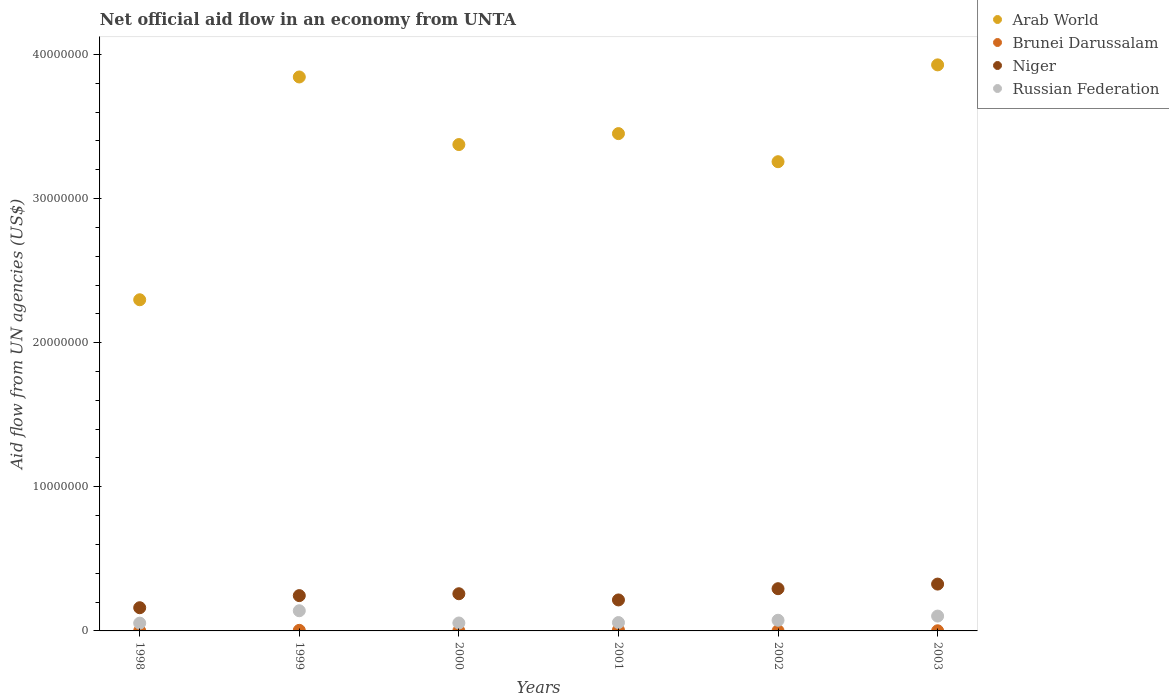How many different coloured dotlines are there?
Offer a very short reply. 4. What is the net official aid flow in Arab World in 1999?
Give a very brief answer. 3.84e+07. Across all years, what is the maximum net official aid flow in Russian Federation?
Your response must be concise. 1.40e+06. Across all years, what is the minimum net official aid flow in Russian Federation?
Provide a succinct answer. 5.40e+05. What is the total net official aid flow in Brunei Darussalam in the graph?
Offer a terse response. 1.40e+05. What is the difference between the net official aid flow in Arab World in 2000 and that in 2003?
Make the answer very short. -5.53e+06. What is the difference between the net official aid flow in Russian Federation in 2002 and the net official aid flow in Arab World in 1999?
Provide a succinct answer. -3.77e+07. What is the average net official aid flow in Arab World per year?
Offer a very short reply. 3.36e+07. In the year 2003, what is the difference between the net official aid flow in Brunei Darussalam and net official aid flow in Niger?
Make the answer very short. -3.24e+06. What is the ratio of the net official aid flow in Russian Federation in 1998 to that in 2002?
Provide a short and direct response. 0.73. Is the net official aid flow in Arab World in 2001 less than that in 2003?
Offer a terse response. Yes. Is the difference between the net official aid flow in Brunei Darussalam in 1999 and 2001 greater than the difference between the net official aid flow in Niger in 1999 and 2001?
Make the answer very short. No. What is the difference between the highest and the second highest net official aid flow in Russian Federation?
Provide a succinct answer. 3.70e+05. What is the difference between the highest and the lowest net official aid flow in Brunei Darussalam?
Your answer should be compact. 5.00e+04. Is the sum of the net official aid flow in Niger in 1998 and 2001 greater than the maximum net official aid flow in Arab World across all years?
Your response must be concise. No. Does the net official aid flow in Niger monotonically increase over the years?
Make the answer very short. No. Is the net official aid flow in Arab World strictly greater than the net official aid flow in Brunei Darussalam over the years?
Keep it short and to the point. Yes. Is the net official aid flow in Brunei Darussalam strictly less than the net official aid flow in Arab World over the years?
Make the answer very short. Yes. How many dotlines are there?
Your answer should be compact. 4. How many years are there in the graph?
Offer a very short reply. 6. What is the difference between two consecutive major ticks on the Y-axis?
Offer a terse response. 1.00e+07. Are the values on the major ticks of Y-axis written in scientific E-notation?
Keep it short and to the point. No. How many legend labels are there?
Make the answer very short. 4. How are the legend labels stacked?
Offer a very short reply. Vertical. What is the title of the graph?
Make the answer very short. Net official aid flow in an economy from UNTA. What is the label or title of the X-axis?
Offer a very short reply. Years. What is the label or title of the Y-axis?
Make the answer very short. Aid flow from UN agencies (US$). What is the Aid flow from UN agencies (US$) of Arab World in 1998?
Your answer should be compact. 2.30e+07. What is the Aid flow from UN agencies (US$) in Niger in 1998?
Provide a short and direct response. 1.61e+06. What is the Aid flow from UN agencies (US$) in Russian Federation in 1998?
Offer a terse response. 5.40e+05. What is the Aid flow from UN agencies (US$) of Arab World in 1999?
Ensure brevity in your answer.  3.84e+07. What is the Aid flow from UN agencies (US$) in Brunei Darussalam in 1999?
Provide a succinct answer. 4.00e+04. What is the Aid flow from UN agencies (US$) of Niger in 1999?
Ensure brevity in your answer.  2.45e+06. What is the Aid flow from UN agencies (US$) in Russian Federation in 1999?
Provide a succinct answer. 1.40e+06. What is the Aid flow from UN agencies (US$) of Arab World in 2000?
Your response must be concise. 3.38e+07. What is the Aid flow from UN agencies (US$) of Brunei Darussalam in 2000?
Give a very brief answer. 10000. What is the Aid flow from UN agencies (US$) in Niger in 2000?
Keep it short and to the point. 2.58e+06. What is the Aid flow from UN agencies (US$) in Arab World in 2001?
Your response must be concise. 3.45e+07. What is the Aid flow from UN agencies (US$) of Niger in 2001?
Your response must be concise. 2.15e+06. What is the Aid flow from UN agencies (US$) in Russian Federation in 2001?
Make the answer very short. 5.80e+05. What is the Aid flow from UN agencies (US$) of Arab World in 2002?
Your answer should be very brief. 3.26e+07. What is the Aid flow from UN agencies (US$) in Niger in 2002?
Your response must be concise. 2.93e+06. What is the Aid flow from UN agencies (US$) of Russian Federation in 2002?
Your answer should be very brief. 7.40e+05. What is the Aid flow from UN agencies (US$) in Arab World in 2003?
Offer a very short reply. 3.93e+07. What is the Aid flow from UN agencies (US$) in Brunei Darussalam in 2003?
Your response must be concise. 10000. What is the Aid flow from UN agencies (US$) in Niger in 2003?
Offer a terse response. 3.25e+06. What is the Aid flow from UN agencies (US$) of Russian Federation in 2003?
Provide a short and direct response. 1.03e+06. Across all years, what is the maximum Aid flow from UN agencies (US$) of Arab World?
Make the answer very short. 3.93e+07. Across all years, what is the maximum Aid flow from UN agencies (US$) of Niger?
Provide a succinct answer. 3.25e+06. Across all years, what is the maximum Aid flow from UN agencies (US$) of Russian Federation?
Keep it short and to the point. 1.40e+06. Across all years, what is the minimum Aid flow from UN agencies (US$) of Arab World?
Offer a terse response. 2.30e+07. Across all years, what is the minimum Aid flow from UN agencies (US$) of Niger?
Make the answer very short. 1.61e+06. Across all years, what is the minimum Aid flow from UN agencies (US$) in Russian Federation?
Your response must be concise. 5.40e+05. What is the total Aid flow from UN agencies (US$) of Arab World in the graph?
Make the answer very short. 2.02e+08. What is the total Aid flow from UN agencies (US$) of Niger in the graph?
Make the answer very short. 1.50e+07. What is the total Aid flow from UN agencies (US$) in Russian Federation in the graph?
Provide a succinct answer. 4.84e+06. What is the difference between the Aid flow from UN agencies (US$) of Arab World in 1998 and that in 1999?
Your answer should be very brief. -1.55e+07. What is the difference between the Aid flow from UN agencies (US$) of Niger in 1998 and that in 1999?
Offer a very short reply. -8.40e+05. What is the difference between the Aid flow from UN agencies (US$) in Russian Federation in 1998 and that in 1999?
Give a very brief answer. -8.60e+05. What is the difference between the Aid flow from UN agencies (US$) of Arab World in 1998 and that in 2000?
Ensure brevity in your answer.  -1.08e+07. What is the difference between the Aid flow from UN agencies (US$) of Niger in 1998 and that in 2000?
Make the answer very short. -9.70e+05. What is the difference between the Aid flow from UN agencies (US$) in Arab World in 1998 and that in 2001?
Provide a succinct answer. -1.15e+07. What is the difference between the Aid flow from UN agencies (US$) of Brunei Darussalam in 1998 and that in 2001?
Offer a terse response. -5.00e+04. What is the difference between the Aid flow from UN agencies (US$) in Niger in 1998 and that in 2001?
Offer a terse response. -5.40e+05. What is the difference between the Aid flow from UN agencies (US$) in Russian Federation in 1998 and that in 2001?
Provide a short and direct response. -4.00e+04. What is the difference between the Aid flow from UN agencies (US$) of Arab World in 1998 and that in 2002?
Ensure brevity in your answer.  -9.58e+06. What is the difference between the Aid flow from UN agencies (US$) of Niger in 1998 and that in 2002?
Ensure brevity in your answer.  -1.32e+06. What is the difference between the Aid flow from UN agencies (US$) of Russian Federation in 1998 and that in 2002?
Offer a terse response. -2.00e+05. What is the difference between the Aid flow from UN agencies (US$) of Arab World in 1998 and that in 2003?
Your answer should be very brief. -1.63e+07. What is the difference between the Aid flow from UN agencies (US$) in Niger in 1998 and that in 2003?
Provide a short and direct response. -1.64e+06. What is the difference between the Aid flow from UN agencies (US$) of Russian Federation in 1998 and that in 2003?
Offer a terse response. -4.90e+05. What is the difference between the Aid flow from UN agencies (US$) of Arab World in 1999 and that in 2000?
Make the answer very short. 4.69e+06. What is the difference between the Aid flow from UN agencies (US$) in Russian Federation in 1999 and that in 2000?
Ensure brevity in your answer.  8.50e+05. What is the difference between the Aid flow from UN agencies (US$) of Arab World in 1999 and that in 2001?
Make the answer very short. 3.93e+06. What is the difference between the Aid flow from UN agencies (US$) in Brunei Darussalam in 1999 and that in 2001?
Your response must be concise. -2.00e+04. What is the difference between the Aid flow from UN agencies (US$) of Russian Federation in 1999 and that in 2001?
Keep it short and to the point. 8.20e+05. What is the difference between the Aid flow from UN agencies (US$) of Arab World in 1999 and that in 2002?
Your answer should be compact. 5.88e+06. What is the difference between the Aid flow from UN agencies (US$) of Brunei Darussalam in 1999 and that in 2002?
Offer a terse response. 3.00e+04. What is the difference between the Aid flow from UN agencies (US$) of Niger in 1999 and that in 2002?
Provide a succinct answer. -4.80e+05. What is the difference between the Aid flow from UN agencies (US$) of Russian Federation in 1999 and that in 2002?
Make the answer very short. 6.60e+05. What is the difference between the Aid flow from UN agencies (US$) in Arab World in 1999 and that in 2003?
Offer a very short reply. -8.40e+05. What is the difference between the Aid flow from UN agencies (US$) in Niger in 1999 and that in 2003?
Offer a very short reply. -8.00e+05. What is the difference between the Aid flow from UN agencies (US$) in Arab World in 2000 and that in 2001?
Your answer should be very brief. -7.60e+05. What is the difference between the Aid flow from UN agencies (US$) in Niger in 2000 and that in 2001?
Your response must be concise. 4.30e+05. What is the difference between the Aid flow from UN agencies (US$) of Arab World in 2000 and that in 2002?
Your answer should be very brief. 1.19e+06. What is the difference between the Aid flow from UN agencies (US$) in Brunei Darussalam in 2000 and that in 2002?
Ensure brevity in your answer.  0. What is the difference between the Aid flow from UN agencies (US$) in Niger in 2000 and that in 2002?
Make the answer very short. -3.50e+05. What is the difference between the Aid flow from UN agencies (US$) of Russian Federation in 2000 and that in 2002?
Ensure brevity in your answer.  -1.90e+05. What is the difference between the Aid flow from UN agencies (US$) in Arab World in 2000 and that in 2003?
Provide a succinct answer. -5.53e+06. What is the difference between the Aid flow from UN agencies (US$) of Brunei Darussalam in 2000 and that in 2003?
Make the answer very short. 0. What is the difference between the Aid flow from UN agencies (US$) in Niger in 2000 and that in 2003?
Your answer should be very brief. -6.70e+05. What is the difference between the Aid flow from UN agencies (US$) in Russian Federation in 2000 and that in 2003?
Ensure brevity in your answer.  -4.80e+05. What is the difference between the Aid flow from UN agencies (US$) of Arab World in 2001 and that in 2002?
Your answer should be very brief. 1.95e+06. What is the difference between the Aid flow from UN agencies (US$) in Brunei Darussalam in 2001 and that in 2002?
Keep it short and to the point. 5.00e+04. What is the difference between the Aid flow from UN agencies (US$) of Niger in 2001 and that in 2002?
Provide a short and direct response. -7.80e+05. What is the difference between the Aid flow from UN agencies (US$) of Arab World in 2001 and that in 2003?
Offer a terse response. -4.77e+06. What is the difference between the Aid flow from UN agencies (US$) of Brunei Darussalam in 2001 and that in 2003?
Your answer should be very brief. 5.00e+04. What is the difference between the Aid flow from UN agencies (US$) in Niger in 2001 and that in 2003?
Give a very brief answer. -1.10e+06. What is the difference between the Aid flow from UN agencies (US$) of Russian Federation in 2001 and that in 2003?
Give a very brief answer. -4.50e+05. What is the difference between the Aid flow from UN agencies (US$) in Arab World in 2002 and that in 2003?
Ensure brevity in your answer.  -6.72e+06. What is the difference between the Aid flow from UN agencies (US$) of Brunei Darussalam in 2002 and that in 2003?
Keep it short and to the point. 0. What is the difference between the Aid flow from UN agencies (US$) of Niger in 2002 and that in 2003?
Keep it short and to the point. -3.20e+05. What is the difference between the Aid flow from UN agencies (US$) in Arab World in 1998 and the Aid flow from UN agencies (US$) in Brunei Darussalam in 1999?
Provide a succinct answer. 2.29e+07. What is the difference between the Aid flow from UN agencies (US$) of Arab World in 1998 and the Aid flow from UN agencies (US$) of Niger in 1999?
Your answer should be compact. 2.05e+07. What is the difference between the Aid flow from UN agencies (US$) of Arab World in 1998 and the Aid flow from UN agencies (US$) of Russian Federation in 1999?
Provide a succinct answer. 2.16e+07. What is the difference between the Aid flow from UN agencies (US$) in Brunei Darussalam in 1998 and the Aid flow from UN agencies (US$) in Niger in 1999?
Make the answer very short. -2.44e+06. What is the difference between the Aid flow from UN agencies (US$) in Brunei Darussalam in 1998 and the Aid flow from UN agencies (US$) in Russian Federation in 1999?
Make the answer very short. -1.39e+06. What is the difference between the Aid flow from UN agencies (US$) of Niger in 1998 and the Aid flow from UN agencies (US$) of Russian Federation in 1999?
Your answer should be very brief. 2.10e+05. What is the difference between the Aid flow from UN agencies (US$) of Arab World in 1998 and the Aid flow from UN agencies (US$) of Brunei Darussalam in 2000?
Provide a short and direct response. 2.30e+07. What is the difference between the Aid flow from UN agencies (US$) of Arab World in 1998 and the Aid flow from UN agencies (US$) of Niger in 2000?
Keep it short and to the point. 2.04e+07. What is the difference between the Aid flow from UN agencies (US$) of Arab World in 1998 and the Aid flow from UN agencies (US$) of Russian Federation in 2000?
Your answer should be compact. 2.24e+07. What is the difference between the Aid flow from UN agencies (US$) in Brunei Darussalam in 1998 and the Aid flow from UN agencies (US$) in Niger in 2000?
Ensure brevity in your answer.  -2.57e+06. What is the difference between the Aid flow from UN agencies (US$) in Brunei Darussalam in 1998 and the Aid flow from UN agencies (US$) in Russian Federation in 2000?
Offer a terse response. -5.40e+05. What is the difference between the Aid flow from UN agencies (US$) in Niger in 1998 and the Aid flow from UN agencies (US$) in Russian Federation in 2000?
Your response must be concise. 1.06e+06. What is the difference between the Aid flow from UN agencies (US$) in Arab World in 1998 and the Aid flow from UN agencies (US$) in Brunei Darussalam in 2001?
Make the answer very short. 2.29e+07. What is the difference between the Aid flow from UN agencies (US$) of Arab World in 1998 and the Aid flow from UN agencies (US$) of Niger in 2001?
Ensure brevity in your answer.  2.08e+07. What is the difference between the Aid flow from UN agencies (US$) of Arab World in 1998 and the Aid flow from UN agencies (US$) of Russian Federation in 2001?
Provide a succinct answer. 2.24e+07. What is the difference between the Aid flow from UN agencies (US$) in Brunei Darussalam in 1998 and the Aid flow from UN agencies (US$) in Niger in 2001?
Provide a succinct answer. -2.14e+06. What is the difference between the Aid flow from UN agencies (US$) of Brunei Darussalam in 1998 and the Aid flow from UN agencies (US$) of Russian Federation in 2001?
Offer a terse response. -5.70e+05. What is the difference between the Aid flow from UN agencies (US$) in Niger in 1998 and the Aid flow from UN agencies (US$) in Russian Federation in 2001?
Offer a terse response. 1.03e+06. What is the difference between the Aid flow from UN agencies (US$) of Arab World in 1998 and the Aid flow from UN agencies (US$) of Brunei Darussalam in 2002?
Give a very brief answer. 2.30e+07. What is the difference between the Aid flow from UN agencies (US$) in Arab World in 1998 and the Aid flow from UN agencies (US$) in Niger in 2002?
Your answer should be very brief. 2.00e+07. What is the difference between the Aid flow from UN agencies (US$) in Arab World in 1998 and the Aid flow from UN agencies (US$) in Russian Federation in 2002?
Your response must be concise. 2.22e+07. What is the difference between the Aid flow from UN agencies (US$) in Brunei Darussalam in 1998 and the Aid flow from UN agencies (US$) in Niger in 2002?
Your response must be concise. -2.92e+06. What is the difference between the Aid flow from UN agencies (US$) in Brunei Darussalam in 1998 and the Aid flow from UN agencies (US$) in Russian Federation in 2002?
Ensure brevity in your answer.  -7.30e+05. What is the difference between the Aid flow from UN agencies (US$) in Niger in 1998 and the Aid flow from UN agencies (US$) in Russian Federation in 2002?
Offer a terse response. 8.70e+05. What is the difference between the Aid flow from UN agencies (US$) of Arab World in 1998 and the Aid flow from UN agencies (US$) of Brunei Darussalam in 2003?
Your answer should be compact. 2.30e+07. What is the difference between the Aid flow from UN agencies (US$) of Arab World in 1998 and the Aid flow from UN agencies (US$) of Niger in 2003?
Give a very brief answer. 1.97e+07. What is the difference between the Aid flow from UN agencies (US$) of Arab World in 1998 and the Aid flow from UN agencies (US$) of Russian Federation in 2003?
Offer a very short reply. 2.20e+07. What is the difference between the Aid flow from UN agencies (US$) in Brunei Darussalam in 1998 and the Aid flow from UN agencies (US$) in Niger in 2003?
Ensure brevity in your answer.  -3.24e+06. What is the difference between the Aid flow from UN agencies (US$) in Brunei Darussalam in 1998 and the Aid flow from UN agencies (US$) in Russian Federation in 2003?
Your answer should be compact. -1.02e+06. What is the difference between the Aid flow from UN agencies (US$) of Niger in 1998 and the Aid flow from UN agencies (US$) of Russian Federation in 2003?
Provide a short and direct response. 5.80e+05. What is the difference between the Aid flow from UN agencies (US$) of Arab World in 1999 and the Aid flow from UN agencies (US$) of Brunei Darussalam in 2000?
Give a very brief answer. 3.84e+07. What is the difference between the Aid flow from UN agencies (US$) in Arab World in 1999 and the Aid flow from UN agencies (US$) in Niger in 2000?
Your response must be concise. 3.59e+07. What is the difference between the Aid flow from UN agencies (US$) in Arab World in 1999 and the Aid flow from UN agencies (US$) in Russian Federation in 2000?
Offer a very short reply. 3.79e+07. What is the difference between the Aid flow from UN agencies (US$) of Brunei Darussalam in 1999 and the Aid flow from UN agencies (US$) of Niger in 2000?
Provide a succinct answer. -2.54e+06. What is the difference between the Aid flow from UN agencies (US$) in Brunei Darussalam in 1999 and the Aid flow from UN agencies (US$) in Russian Federation in 2000?
Give a very brief answer. -5.10e+05. What is the difference between the Aid flow from UN agencies (US$) of Niger in 1999 and the Aid flow from UN agencies (US$) of Russian Federation in 2000?
Provide a succinct answer. 1.90e+06. What is the difference between the Aid flow from UN agencies (US$) of Arab World in 1999 and the Aid flow from UN agencies (US$) of Brunei Darussalam in 2001?
Give a very brief answer. 3.84e+07. What is the difference between the Aid flow from UN agencies (US$) in Arab World in 1999 and the Aid flow from UN agencies (US$) in Niger in 2001?
Keep it short and to the point. 3.63e+07. What is the difference between the Aid flow from UN agencies (US$) in Arab World in 1999 and the Aid flow from UN agencies (US$) in Russian Federation in 2001?
Your answer should be very brief. 3.79e+07. What is the difference between the Aid flow from UN agencies (US$) in Brunei Darussalam in 1999 and the Aid flow from UN agencies (US$) in Niger in 2001?
Offer a very short reply. -2.11e+06. What is the difference between the Aid flow from UN agencies (US$) of Brunei Darussalam in 1999 and the Aid flow from UN agencies (US$) of Russian Federation in 2001?
Offer a very short reply. -5.40e+05. What is the difference between the Aid flow from UN agencies (US$) of Niger in 1999 and the Aid flow from UN agencies (US$) of Russian Federation in 2001?
Your answer should be very brief. 1.87e+06. What is the difference between the Aid flow from UN agencies (US$) in Arab World in 1999 and the Aid flow from UN agencies (US$) in Brunei Darussalam in 2002?
Your response must be concise. 3.84e+07. What is the difference between the Aid flow from UN agencies (US$) of Arab World in 1999 and the Aid flow from UN agencies (US$) of Niger in 2002?
Your response must be concise. 3.55e+07. What is the difference between the Aid flow from UN agencies (US$) in Arab World in 1999 and the Aid flow from UN agencies (US$) in Russian Federation in 2002?
Ensure brevity in your answer.  3.77e+07. What is the difference between the Aid flow from UN agencies (US$) of Brunei Darussalam in 1999 and the Aid flow from UN agencies (US$) of Niger in 2002?
Ensure brevity in your answer.  -2.89e+06. What is the difference between the Aid flow from UN agencies (US$) in Brunei Darussalam in 1999 and the Aid flow from UN agencies (US$) in Russian Federation in 2002?
Give a very brief answer. -7.00e+05. What is the difference between the Aid flow from UN agencies (US$) in Niger in 1999 and the Aid flow from UN agencies (US$) in Russian Federation in 2002?
Provide a succinct answer. 1.71e+06. What is the difference between the Aid flow from UN agencies (US$) of Arab World in 1999 and the Aid flow from UN agencies (US$) of Brunei Darussalam in 2003?
Your answer should be very brief. 3.84e+07. What is the difference between the Aid flow from UN agencies (US$) in Arab World in 1999 and the Aid flow from UN agencies (US$) in Niger in 2003?
Your answer should be compact. 3.52e+07. What is the difference between the Aid flow from UN agencies (US$) in Arab World in 1999 and the Aid flow from UN agencies (US$) in Russian Federation in 2003?
Provide a succinct answer. 3.74e+07. What is the difference between the Aid flow from UN agencies (US$) in Brunei Darussalam in 1999 and the Aid flow from UN agencies (US$) in Niger in 2003?
Give a very brief answer. -3.21e+06. What is the difference between the Aid flow from UN agencies (US$) of Brunei Darussalam in 1999 and the Aid flow from UN agencies (US$) of Russian Federation in 2003?
Offer a terse response. -9.90e+05. What is the difference between the Aid flow from UN agencies (US$) in Niger in 1999 and the Aid flow from UN agencies (US$) in Russian Federation in 2003?
Keep it short and to the point. 1.42e+06. What is the difference between the Aid flow from UN agencies (US$) in Arab World in 2000 and the Aid flow from UN agencies (US$) in Brunei Darussalam in 2001?
Provide a short and direct response. 3.37e+07. What is the difference between the Aid flow from UN agencies (US$) of Arab World in 2000 and the Aid flow from UN agencies (US$) of Niger in 2001?
Provide a succinct answer. 3.16e+07. What is the difference between the Aid flow from UN agencies (US$) in Arab World in 2000 and the Aid flow from UN agencies (US$) in Russian Federation in 2001?
Make the answer very short. 3.32e+07. What is the difference between the Aid flow from UN agencies (US$) in Brunei Darussalam in 2000 and the Aid flow from UN agencies (US$) in Niger in 2001?
Your response must be concise. -2.14e+06. What is the difference between the Aid flow from UN agencies (US$) in Brunei Darussalam in 2000 and the Aid flow from UN agencies (US$) in Russian Federation in 2001?
Keep it short and to the point. -5.70e+05. What is the difference between the Aid flow from UN agencies (US$) in Arab World in 2000 and the Aid flow from UN agencies (US$) in Brunei Darussalam in 2002?
Your response must be concise. 3.37e+07. What is the difference between the Aid flow from UN agencies (US$) in Arab World in 2000 and the Aid flow from UN agencies (US$) in Niger in 2002?
Offer a terse response. 3.08e+07. What is the difference between the Aid flow from UN agencies (US$) in Arab World in 2000 and the Aid flow from UN agencies (US$) in Russian Federation in 2002?
Provide a short and direct response. 3.30e+07. What is the difference between the Aid flow from UN agencies (US$) of Brunei Darussalam in 2000 and the Aid flow from UN agencies (US$) of Niger in 2002?
Your response must be concise. -2.92e+06. What is the difference between the Aid flow from UN agencies (US$) of Brunei Darussalam in 2000 and the Aid flow from UN agencies (US$) of Russian Federation in 2002?
Offer a very short reply. -7.30e+05. What is the difference between the Aid flow from UN agencies (US$) of Niger in 2000 and the Aid flow from UN agencies (US$) of Russian Federation in 2002?
Keep it short and to the point. 1.84e+06. What is the difference between the Aid flow from UN agencies (US$) of Arab World in 2000 and the Aid flow from UN agencies (US$) of Brunei Darussalam in 2003?
Provide a short and direct response. 3.37e+07. What is the difference between the Aid flow from UN agencies (US$) in Arab World in 2000 and the Aid flow from UN agencies (US$) in Niger in 2003?
Offer a terse response. 3.05e+07. What is the difference between the Aid flow from UN agencies (US$) of Arab World in 2000 and the Aid flow from UN agencies (US$) of Russian Federation in 2003?
Give a very brief answer. 3.27e+07. What is the difference between the Aid flow from UN agencies (US$) of Brunei Darussalam in 2000 and the Aid flow from UN agencies (US$) of Niger in 2003?
Provide a short and direct response. -3.24e+06. What is the difference between the Aid flow from UN agencies (US$) in Brunei Darussalam in 2000 and the Aid flow from UN agencies (US$) in Russian Federation in 2003?
Provide a short and direct response. -1.02e+06. What is the difference between the Aid flow from UN agencies (US$) in Niger in 2000 and the Aid flow from UN agencies (US$) in Russian Federation in 2003?
Offer a terse response. 1.55e+06. What is the difference between the Aid flow from UN agencies (US$) in Arab World in 2001 and the Aid flow from UN agencies (US$) in Brunei Darussalam in 2002?
Ensure brevity in your answer.  3.45e+07. What is the difference between the Aid flow from UN agencies (US$) in Arab World in 2001 and the Aid flow from UN agencies (US$) in Niger in 2002?
Your answer should be very brief. 3.16e+07. What is the difference between the Aid flow from UN agencies (US$) in Arab World in 2001 and the Aid flow from UN agencies (US$) in Russian Federation in 2002?
Make the answer very short. 3.38e+07. What is the difference between the Aid flow from UN agencies (US$) of Brunei Darussalam in 2001 and the Aid flow from UN agencies (US$) of Niger in 2002?
Ensure brevity in your answer.  -2.87e+06. What is the difference between the Aid flow from UN agencies (US$) in Brunei Darussalam in 2001 and the Aid flow from UN agencies (US$) in Russian Federation in 2002?
Provide a succinct answer. -6.80e+05. What is the difference between the Aid flow from UN agencies (US$) of Niger in 2001 and the Aid flow from UN agencies (US$) of Russian Federation in 2002?
Give a very brief answer. 1.41e+06. What is the difference between the Aid flow from UN agencies (US$) in Arab World in 2001 and the Aid flow from UN agencies (US$) in Brunei Darussalam in 2003?
Provide a succinct answer. 3.45e+07. What is the difference between the Aid flow from UN agencies (US$) in Arab World in 2001 and the Aid flow from UN agencies (US$) in Niger in 2003?
Give a very brief answer. 3.13e+07. What is the difference between the Aid flow from UN agencies (US$) of Arab World in 2001 and the Aid flow from UN agencies (US$) of Russian Federation in 2003?
Give a very brief answer. 3.35e+07. What is the difference between the Aid flow from UN agencies (US$) of Brunei Darussalam in 2001 and the Aid flow from UN agencies (US$) of Niger in 2003?
Offer a terse response. -3.19e+06. What is the difference between the Aid flow from UN agencies (US$) in Brunei Darussalam in 2001 and the Aid flow from UN agencies (US$) in Russian Federation in 2003?
Keep it short and to the point. -9.70e+05. What is the difference between the Aid flow from UN agencies (US$) of Niger in 2001 and the Aid flow from UN agencies (US$) of Russian Federation in 2003?
Keep it short and to the point. 1.12e+06. What is the difference between the Aid flow from UN agencies (US$) in Arab World in 2002 and the Aid flow from UN agencies (US$) in Brunei Darussalam in 2003?
Offer a very short reply. 3.26e+07. What is the difference between the Aid flow from UN agencies (US$) in Arab World in 2002 and the Aid flow from UN agencies (US$) in Niger in 2003?
Keep it short and to the point. 2.93e+07. What is the difference between the Aid flow from UN agencies (US$) in Arab World in 2002 and the Aid flow from UN agencies (US$) in Russian Federation in 2003?
Ensure brevity in your answer.  3.15e+07. What is the difference between the Aid flow from UN agencies (US$) in Brunei Darussalam in 2002 and the Aid flow from UN agencies (US$) in Niger in 2003?
Offer a terse response. -3.24e+06. What is the difference between the Aid flow from UN agencies (US$) of Brunei Darussalam in 2002 and the Aid flow from UN agencies (US$) of Russian Federation in 2003?
Keep it short and to the point. -1.02e+06. What is the difference between the Aid flow from UN agencies (US$) in Niger in 2002 and the Aid flow from UN agencies (US$) in Russian Federation in 2003?
Your answer should be compact. 1.90e+06. What is the average Aid flow from UN agencies (US$) in Arab World per year?
Provide a short and direct response. 3.36e+07. What is the average Aid flow from UN agencies (US$) in Brunei Darussalam per year?
Make the answer very short. 2.33e+04. What is the average Aid flow from UN agencies (US$) of Niger per year?
Your answer should be very brief. 2.50e+06. What is the average Aid flow from UN agencies (US$) in Russian Federation per year?
Offer a terse response. 8.07e+05. In the year 1998, what is the difference between the Aid flow from UN agencies (US$) of Arab World and Aid flow from UN agencies (US$) of Brunei Darussalam?
Make the answer very short. 2.30e+07. In the year 1998, what is the difference between the Aid flow from UN agencies (US$) in Arab World and Aid flow from UN agencies (US$) in Niger?
Ensure brevity in your answer.  2.14e+07. In the year 1998, what is the difference between the Aid flow from UN agencies (US$) of Arab World and Aid flow from UN agencies (US$) of Russian Federation?
Provide a succinct answer. 2.24e+07. In the year 1998, what is the difference between the Aid flow from UN agencies (US$) in Brunei Darussalam and Aid flow from UN agencies (US$) in Niger?
Ensure brevity in your answer.  -1.60e+06. In the year 1998, what is the difference between the Aid flow from UN agencies (US$) of Brunei Darussalam and Aid flow from UN agencies (US$) of Russian Federation?
Provide a succinct answer. -5.30e+05. In the year 1998, what is the difference between the Aid flow from UN agencies (US$) in Niger and Aid flow from UN agencies (US$) in Russian Federation?
Give a very brief answer. 1.07e+06. In the year 1999, what is the difference between the Aid flow from UN agencies (US$) of Arab World and Aid flow from UN agencies (US$) of Brunei Darussalam?
Offer a very short reply. 3.84e+07. In the year 1999, what is the difference between the Aid flow from UN agencies (US$) of Arab World and Aid flow from UN agencies (US$) of Niger?
Your answer should be compact. 3.60e+07. In the year 1999, what is the difference between the Aid flow from UN agencies (US$) of Arab World and Aid flow from UN agencies (US$) of Russian Federation?
Your answer should be very brief. 3.70e+07. In the year 1999, what is the difference between the Aid flow from UN agencies (US$) in Brunei Darussalam and Aid flow from UN agencies (US$) in Niger?
Your answer should be compact. -2.41e+06. In the year 1999, what is the difference between the Aid flow from UN agencies (US$) of Brunei Darussalam and Aid flow from UN agencies (US$) of Russian Federation?
Your answer should be very brief. -1.36e+06. In the year 1999, what is the difference between the Aid flow from UN agencies (US$) in Niger and Aid flow from UN agencies (US$) in Russian Federation?
Keep it short and to the point. 1.05e+06. In the year 2000, what is the difference between the Aid flow from UN agencies (US$) of Arab World and Aid flow from UN agencies (US$) of Brunei Darussalam?
Make the answer very short. 3.37e+07. In the year 2000, what is the difference between the Aid flow from UN agencies (US$) in Arab World and Aid flow from UN agencies (US$) in Niger?
Provide a short and direct response. 3.12e+07. In the year 2000, what is the difference between the Aid flow from UN agencies (US$) in Arab World and Aid flow from UN agencies (US$) in Russian Federation?
Your answer should be very brief. 3.32e+07. In the year 2000, what is the difference between the Aid flow from UN agencies (US$) in Brunei Darussalam and Aid flow from UN agencies (US$) in Niger?
Offer a terse response. -2.57e+06. In the year 2000, what is the difference between the Aid flow from UN agencies (US$) in Brunei Darussalam and Aid flow from UN agencies (US$) in Russian Federation?
Provide a succinct answer. -5.40e+05. In the year 2000, what is the difference between the Aid flow from UN agencies (US$) in Niger and Aid flow from UN agencies (US$) in Russian Federation?
Provide a short and direct response. 2.03e+06. In the year 2001, what is the difference between the Aid flow from UN agencies (US$) in Arab World and Aid flow from UN agencies (US$) in Brunei Darussalam?
Keep it short and to the point. 3.44e+07. In the year 2001, what is the difference between the Aid flow from UN agencies (US$) of Arab World and Aid flow from UN agencies (US$) of Niger?
Provide a succinct answer. 3.24e+07. In the year 2001, what is the difference between the Aid flow from UN agencies (US$) of Arab World and Aid flow from UN agencies (US$) of Russian Federation?
Your answer should be compact. 3.39e+07. In the year 2001, what is the difference between the Aid flow from UN agencies (US$) in Brunei Darussalam and Aid flow from UN agencies (US$) in Niger?
Offer a very short reply. -2.09e+06. In the year 2001, what is the difference between the Aid flow from UN agencies (US$) in Brunei Darussalam and Aid flow from UN agencies (US$) in Russian Federation?
Offer a very short reply. -5.20e+05. In the year 2001, what is the difference between the Aid flow from UN agencies (US$) of Niger and Aid flow from UN agencies (US$) of Russian Federation?
Provide a short and direct response. 1.57e+06. In the year 2002, what is the difference between the Aid flow from UN agencies (US$) of Arab World and Aid flow from UN agencies (US$) of Brunei Darussalam?
Keep it short and to the point. 3.26e+07. In the year 2002, what is the difference between the Aid flow from UN agencies (US$) in Arab World and Aid flow from UN agencies (US$) in Niger?
Ensure brevity in your answer.  2.96e+07. In the year 2002, what is the difference between the Aid flow from UN agencies (US$) of Arab World and Aid flow from UN agencies (US$) of Russian Federation?
Make the answer very short. 3.18e+07. In the year 2002, what is the difference between the Aid flow from UN agencies (US$) of Brunei Darussalam and Aid flow from UN agencies (US$) of Niger?
Give a very brief answer. -2.92e+06. In the year 2002, what is the difference between the Aid flow from UN agencies (US$) of Brunei Darussalam and Aid flow from UN agencies (US$) of Russian Federation?
Your answer should be very brief. -7.30e+05. In the year 2002, what is the difference between the Aid flow from UN agencies (US$) in Niger and Aid flow from UN agencies (US$) in Russian Federation?
Your answer should be very brief. 2.19e+06. In the year 2003, what is the difference between the Aid flow from UN agencies (US$) of Arab World and Aid flow from UN agencies (US$) of Brunei Darussalam?
Offer a very short reply. 3.93e+07. In the year 2003, what is the difference between the Aid flow from UN agencies (US$) of Arab World and Aid flow from UN agencies (US$) of Niger?
Make the answer very short. 3.60e+07. In the year 2003, what is the difference between the Aid flow from UN agencies (US$) of Arab World and Aid flow from UN agencies (US$) of Russian Federation?
Provide a short and direct response. 3.82e+07. In the year 2003, what is the difference between the Aid flow from UN agencies (US$) in Brunei Darussalam and Aid flow from UN agencies (US$) in Niger?
Give a very brief answer. -3.24e+06. In the year 2003, what is the difference between the Aid flow from UN agencies (US$) in Brunei Darussalam and Aid flow from UN agencies (US$) in Russian Federation?
Keep it short and to the point. -1.02e+06. In the year 2003, what is the difference between the Aid flow from UN agencies (US$) of Niger and Aid flow from UN agencies (US$) of Russian Federation?
Your answer should be very brief. 2.22e+06. What is the ratio of the Aid flow from UN agencies (US$) in Arab World in 1998 to that in 1999?
Provide a short and direct response. 0.6. What is the ratio of the Aid flow from UN agencies (US$) of Niger in 1998 to that in 1999?
Make the answer very short. 0.66. What is the ratio of the Aid flow from UN agencies (US$) of Russian Federation in 1998 to that in 1999?
Your answer should be compact. 0.39. What is the ratio of the Aid flow from UN agencies (US$) of Arab World in 1998 to that in 2000?
Provide a succinct answer. 0.68. What is the ratio of the Aid flow from UN agencies (US$) in Brunei Darussalam in 1998 to that in 2000?
Keep it short and to the point. 1. What is the ratio of the Aid flow from UN agencies (US$) of Niger in 1998 to that in 2000?
Your answer should be compact. 0.62. What is the ratio of the Aid flow from UN agencies (US$) in Russian Federation in 1998 to that in 2000?
Your response must be concise. 0.98. What is the ratio of the Aid flow from UN agencies (US$) in Arab World in 1998 to that in 2001?
Your response must be concise. 0.67. What is the ratio of the Aid flow from UN agencies (US$) in Niger in 1998 to that in 2001?
Offer a terse response. 0.75. What is the ratio of the Aid flow from UN agencies (US$) in Arab World in 1998 to that in 2002?
Offer a very short reply. 0.71. What is the ratio of the Aid flow from UN agencies (US$) in Brunei Darussalam in 1998 to that in 2002?
Provide a succinct answer. 1. What is the ratio of the Aid flow from UN agencies (US$) in Niger in 1998 to that in 2002?
Give a very brief answer. 0.55. What is the ratio of the Aid flow from UN agencies (US$) of Russian Federation in 1998 to that in 2002?
Ensure brevity in your answer.  0.73. What is the ratio of the Aid flow from UN agencies (US$) of Arab World in 1998 to that in 2003?
Offer a terse response. 0.58. What is the ratio of the Aid flow from UN agencies (US$) in Niger in 1998 to that in 2003?
Ensure brevity in your answer.  0.5. What is the ratio of the Aid flow from UN agencies (US$) of Russian Federation in 1998 to that in 2003?
Give a very brief answer. 0.52. What is the ratio of the Aid flow from UN agencies (US$) of Arab World in 1999 to that in 2000?
Ensure brevity in your answer.  1.14. What is the ratio of the Aid flow from UN agencies (US$) in Niger in 1999 to that in 2000?
Provide a short and direct response. 0.95. What is the ratio of the Aid flow from UN agencies (US$) of Russian Federation in 1999 to that in 2000?
Ensure brevity in your answer.  2.55. What is the ratio of the Aid flow from UN agencies (US$) of Arab World in 1999 to that in 2001?
Your response must be concise. 1.11. What is the ratio of the Aid flow from UN agencies (US$) in Niger in 1999 to that in 2001?
Keep it short and to the point. 1.14. What is the ratio of the Aid flow from UN agencies (US$) of Russian Federation in 1999 to that in 2001?
Keep it short and to the point. 2.41. What is the ratio of the Aid flow from UN agencies (US$) of Arab World in 1999 to that in 2002?
Make the answer very short. 1.18. What is the ratio of the Aid flow from UN agencies (US$) of Brunei Darussalam in 1999 to that in 2002?
Provide a succinct answer. 4. What is the ratio of the Aid flow from UN agencies (US$) of Niger in 1999 to that in 2002?
Keep it short and to the point. 0.84. What is the ratio of the Aid flow from UN agencies (US$) in Russian Federation in 1999 to that in 2002?
Make the answer very short. 1.89. What is the ratio of the Aid flow from UN agencies (US$) in Arab World in 1999 to that in 2003?
Make the answer very short. 0.98. What is the ratio of the Aid flow from UN agencies (US$) of Brunei Darussalam in 1999 to that in 2003?
Your answer should be compact. 4. What is the ratio of the Aid flow from UN agencies (US$) in Niger in 1999 to that in 2003?
Offer a terse response. 0.75. What is the ratio of the Aid flow from UN agencies (US$) of Russian Federation in 1999 to that in 2003?
Your answer should be compact. 1.36. What is the ratio of the Aid flow from UN agencies (US$) in Russian Federation in 2000 to that in 2001?
Make the answer very short. 0.95. What is the ratio of the Aid flow from UN agencies (US$) of Arab World in 2000 to that in 2002?
Make the answer very short. 1.04. What is the ratio of the Aid flow from UN agencies (US$) in Brunei Darussalam in 2000 to that in 2002?
Ensure brevity in your answer.  1. What is the ratio of the Aid flow from UN agencies (US$) in Niger in 2000 to that in 2002?
Keep it short and to the point. 0.88. What is the ratio of the Aid flow from UN agencies (US$) of Russian Federation in 2000 to that in 2002?
Keep it short and to the point. 0.74. What is the ratio of the Aid flow from UN agencies (US$) in Arab World in 2000 to that in 2003?
Offer a very short reply. 0.86. What is the ratio of the Aid flow from UN agencies (US$) in Niger in 2000 to that in 2003?
Ensure brevity in your answer.  0.79. What is the ratio of the Aid flow from UN agencies (US$) in Russian Federation in 2000 to that in 2003?
Give a very brief answer. 0.53. What is the ratio of the Aid flow from UN agencies (US$) of Arab World in 2001 to that in 2002?
Offer a terse response. 1.06. What is the ratio of the Aid flow from UN agencies (US$) of Brunei Darussalam in 2001 to that in 2002?
Offer a very short reply. 6. What is the ratio of the Aid flow from UN agencies (US$) in Niger in 2001 to that in 2002?
Offer a very short reply. 0.73. What is the ratio of the Aid flow from UN agencies (US$) in Russian Federation in 2001 to that in 2002?
Your response must be concise. 0.78. What is the ratio of the Aid flow from UN agencies (US$) of Arab World in 2001 to that in 2003?
Give a very brief answer. 0.88. What is the ratio of the Aid flow from UN agencies (US$) of Niger in 2001 to that in 2003?
Provide a short and direct response. 0.66. What is the ratio of the Aid flow from UN agencies (US$) in Russian Federation in 2001 to that in 2003?
Ensure brevity in your answer.  0.56. What is the ratio of the Aid flow from UN agencies (US$) in Arab World in 2002 to that in 2003?
Offer a very short reply. 0.83. What is the ratio of the Aid flow from UN agencies (US$) in Niger in 2002 to that in 2003?
Offer a very short reply. 0.9. What is the ratio of the Aid flow from UN agencies (US$) in Russian Federation in 2002 to that in 2003?
Your answer should be very brief. 0.72. What is the difference between the highest and the second highest Aid flow from UN agencies (US$) of Arab World?
Provide a short and direct response. 8.40e+05. What is the difference between the highest and the second highest Aid flow from UN agencies (US$) of Niger?
Your answer should be very brief. 3.20e+05. What is the difference between the highest and the second highest Aid flow from UN agencies (US$) in Russian Federation?
Ensure brevity in your answer.  3.70e+05. What is the difference between the highest and the lowest Aid flow from UN agencies (US$) in Arab World?
Offer a terse response. 1.63e+07. What is the difference between the highest and the lowest Aid flow from UN agencies (US$) of Brunei Darussalam?
Your response must be concise. 5.00e+04. What is the difference between the highest and the lowest Aid flow from UN agencies (US$) of Niger?
Provide a short and direct response. 1.64e+06. What is the difference between the highest and the lowest Aid flow from UN agencies (US$) of Russian Federation?
Make the answer very short. 8.60e+05. 